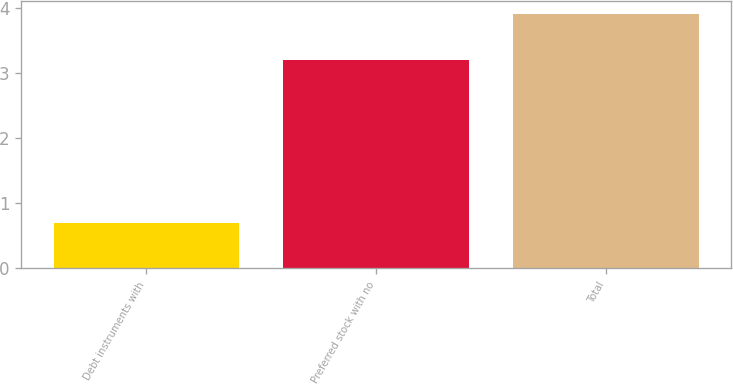<chart> <loc_0><loc_0><loc_500><loc_500><bar_chart><fcel>Debt instruments with<fcel>Preferred stock with no<fcel>Total<nl><fcel>0.7<fcel>3.2<fcel>3.9<nl></chart> 